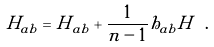Convert formula to latex. <formula><loc_0><loc_0><loc_500><loc_500>H _ { a b } = { \tilde { H } } _ { a b } + \frac { 1 } { n - 1 } h _ { a b } H \ .</formula> 